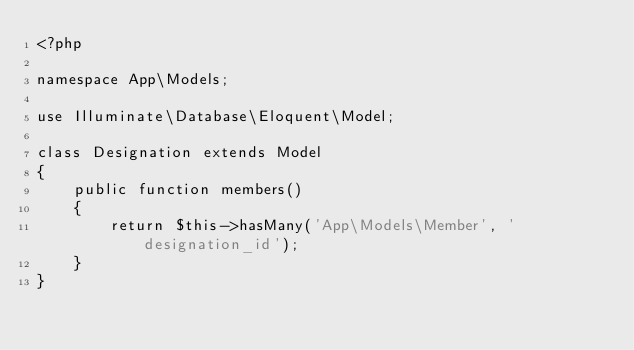<code> <loc_0><loc_0><loc_500><loc_500><_PHP_><?php

namespace App\Models;

use Illuminate\Database\Eloquent\Model;

class Designation extends Model
{
    public function members()
    {
        return $this->hasMany('App\Models\Member', 'designation_id');
    }
}
</code> 